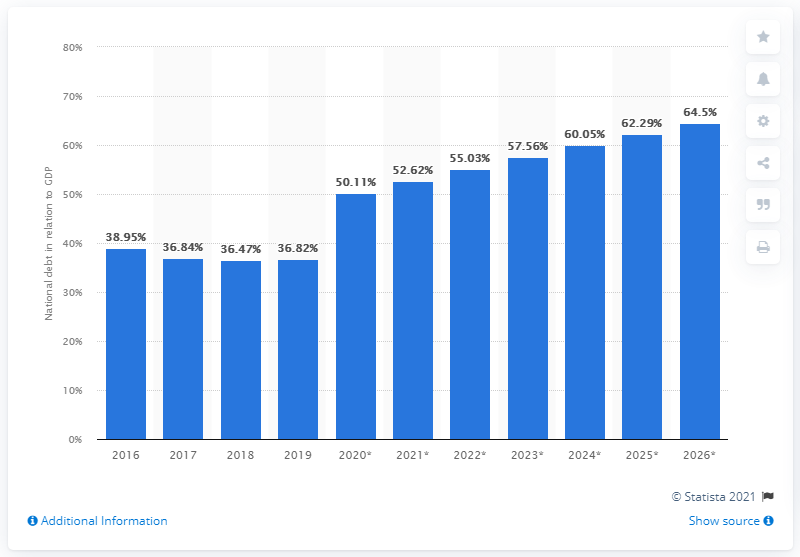Identify some key points in this picture. In 2019, the national debt of Romania accounted for 36.82% of the country's GDP. 